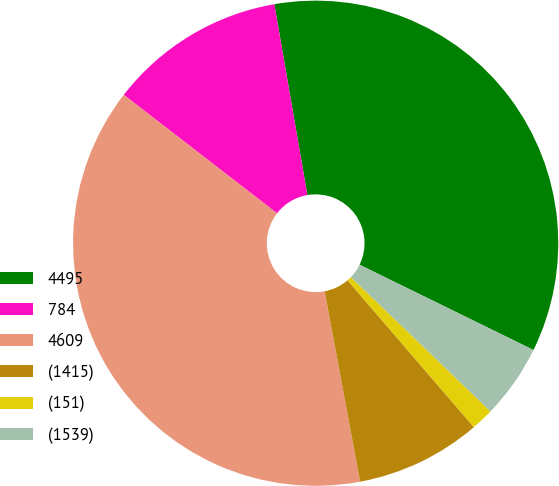<chart> <loc_0><loc_0><loc_500><loc_500><pie_chart><fcel>4495<fcel>784<fcel>4609<fcel>(1415)<fcel>(151)<fcel>(1539)<nl><fcel>34.98%<fcel>11.8%<fcel>38.41%<fcel>8.37%<fcel>1.5%<fcel>4.94%<nl></chart> 